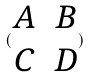Convert formula to latex. <formula><loc_0><loc_0><loc_500><loc_500>( \begin{matrix} A & B \\ C & D \end{matrix} )</formula> 